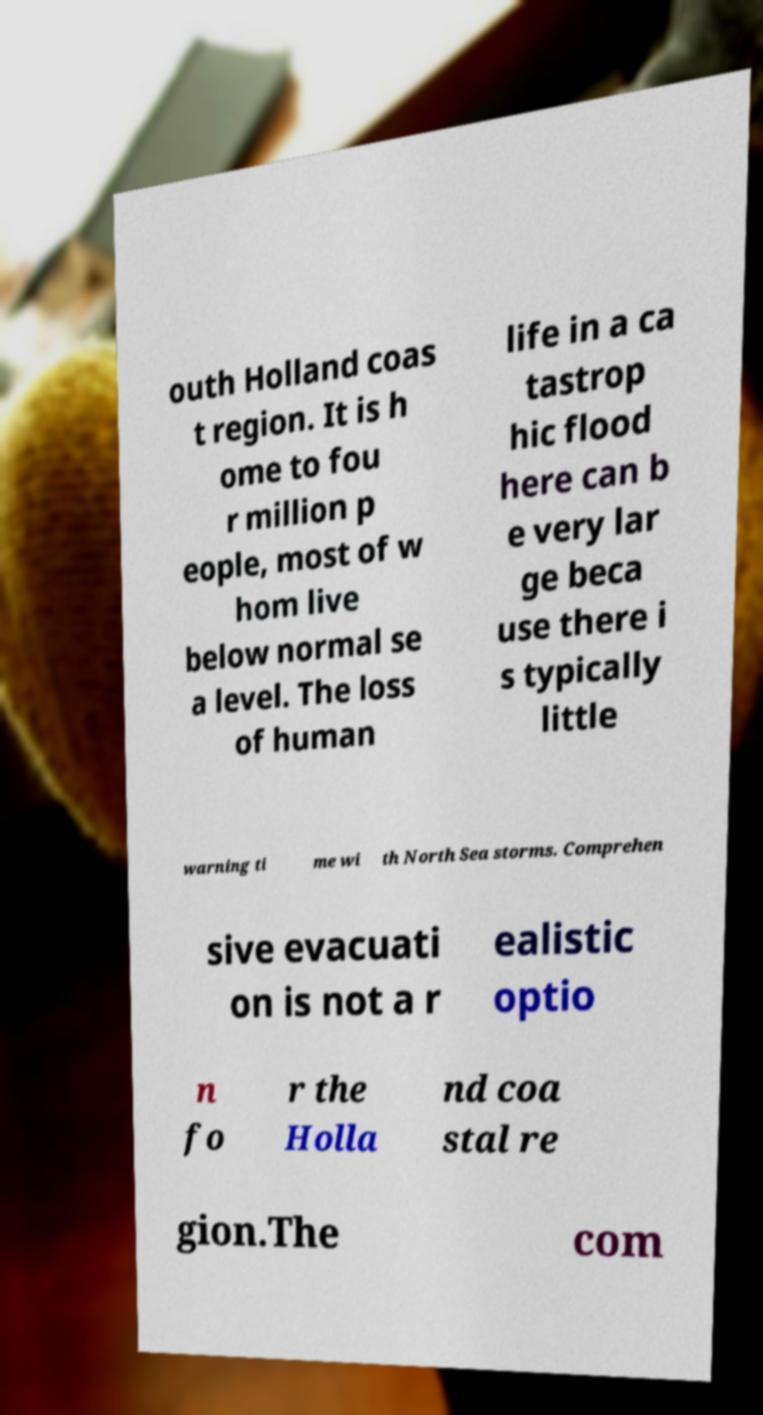Please identify and transcribe the text found in this image. outh Holland coas t region. It is h ome to fou r million p eople, most of w hom live below normal se a level. The loss of human life in a ca tastrop hic flood here can b e very lar ge beca use there i s typically little warning ti me wi th North Sea storms. Comprehen sive evacuati on is not a r ealistic optio n fo r the Holla nd coa stal re gion.The com 